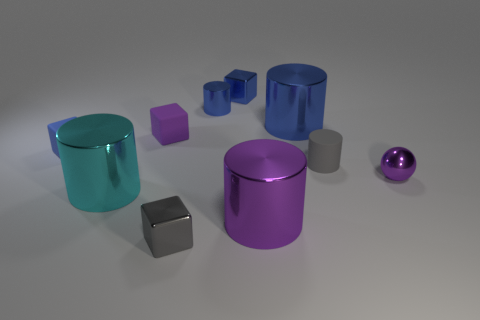Subtract all large blue shiny cylinders. How many cylinders are left? 4 Subtract all gray cubes. How many cubes are left? 3 Subtract all spheres. How many objects are left? 9 Subtract 1 balls. How many balls are left? 0 Subtract all yellow cylinders. How many green blocks are left? 0 Subtract all tiny purple metal balls. Subtract all gray rubber cylinders. How many objects are left? 8 Add 4 large metal things. How many large metal things are left? 7 Add 1 green rubber spheres. How many green rubber spheres exist? 1 Subtract 1 cyan cylinders. How many objects are left? 9 Subtract all brown blocks. Subtract all red cylinders. How many blocks are left? 4 